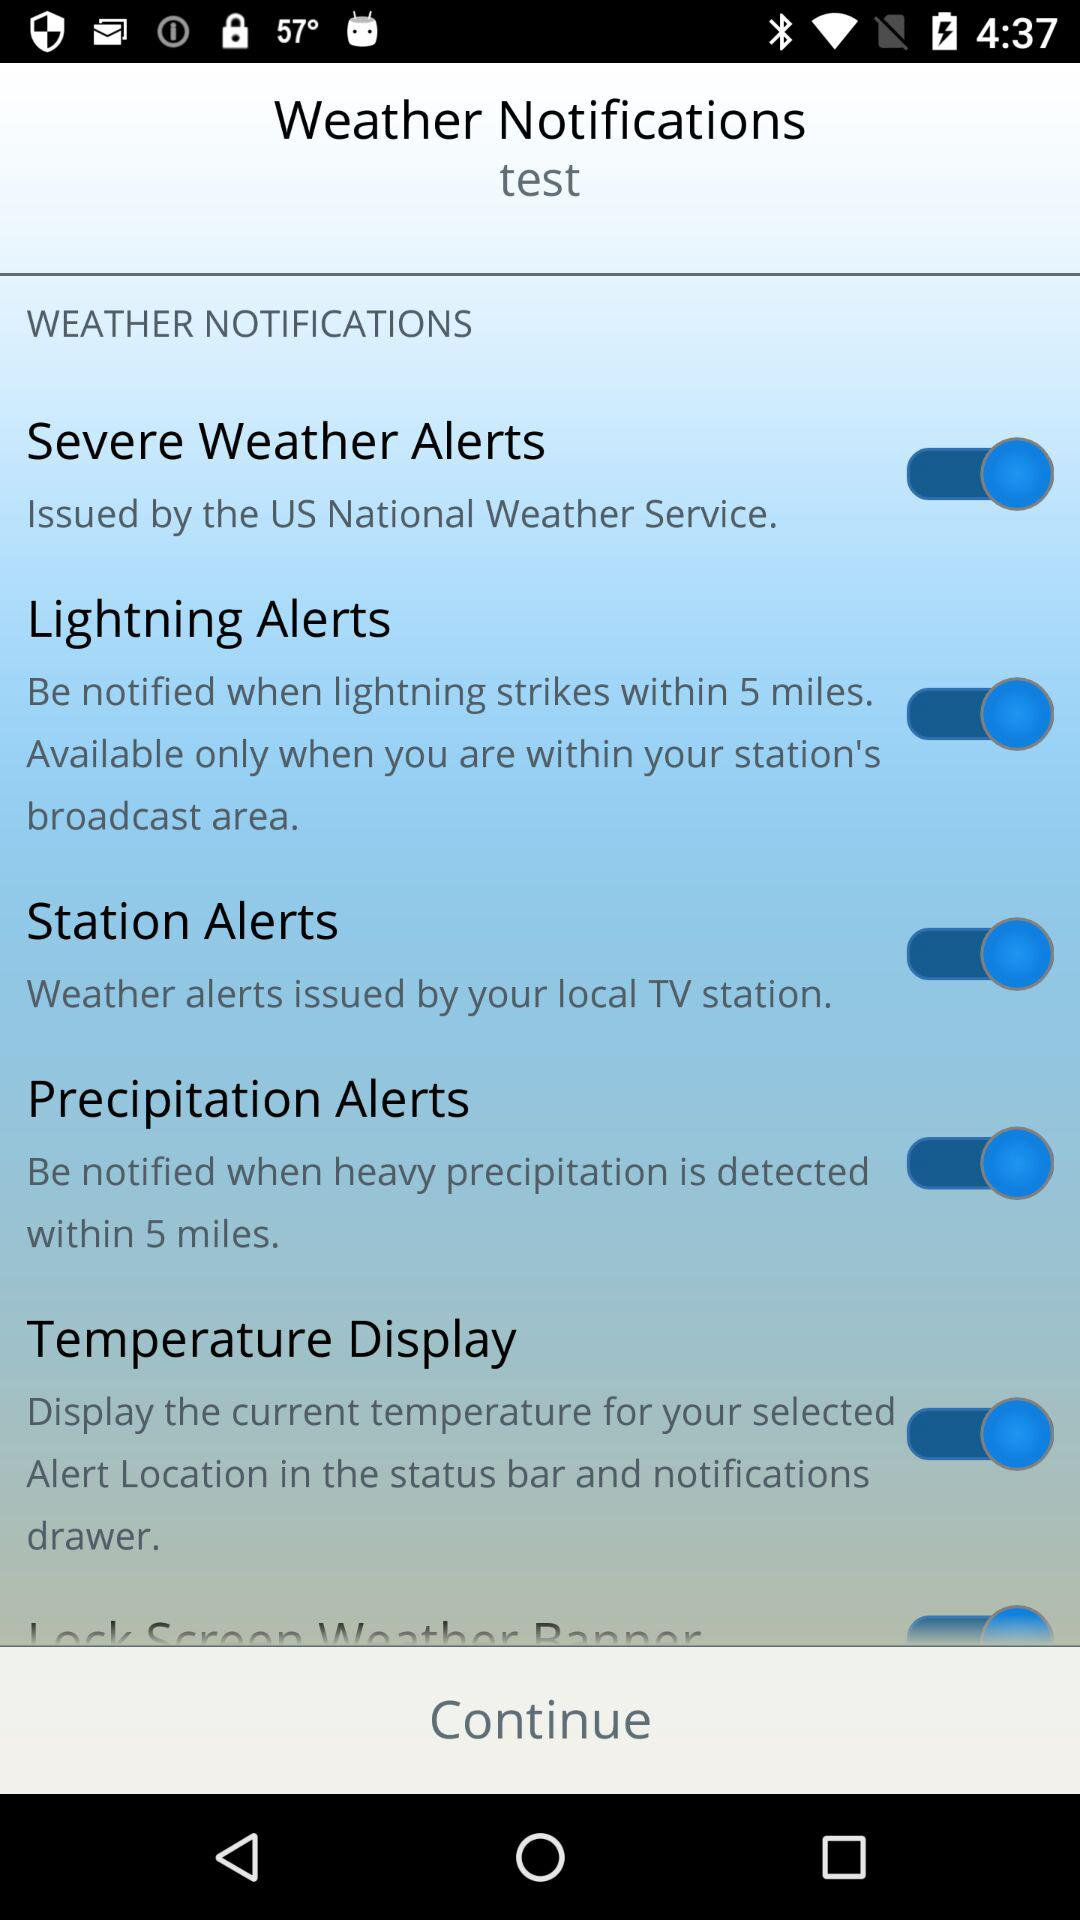What is the status of "Station Alerts"? The status is on. 